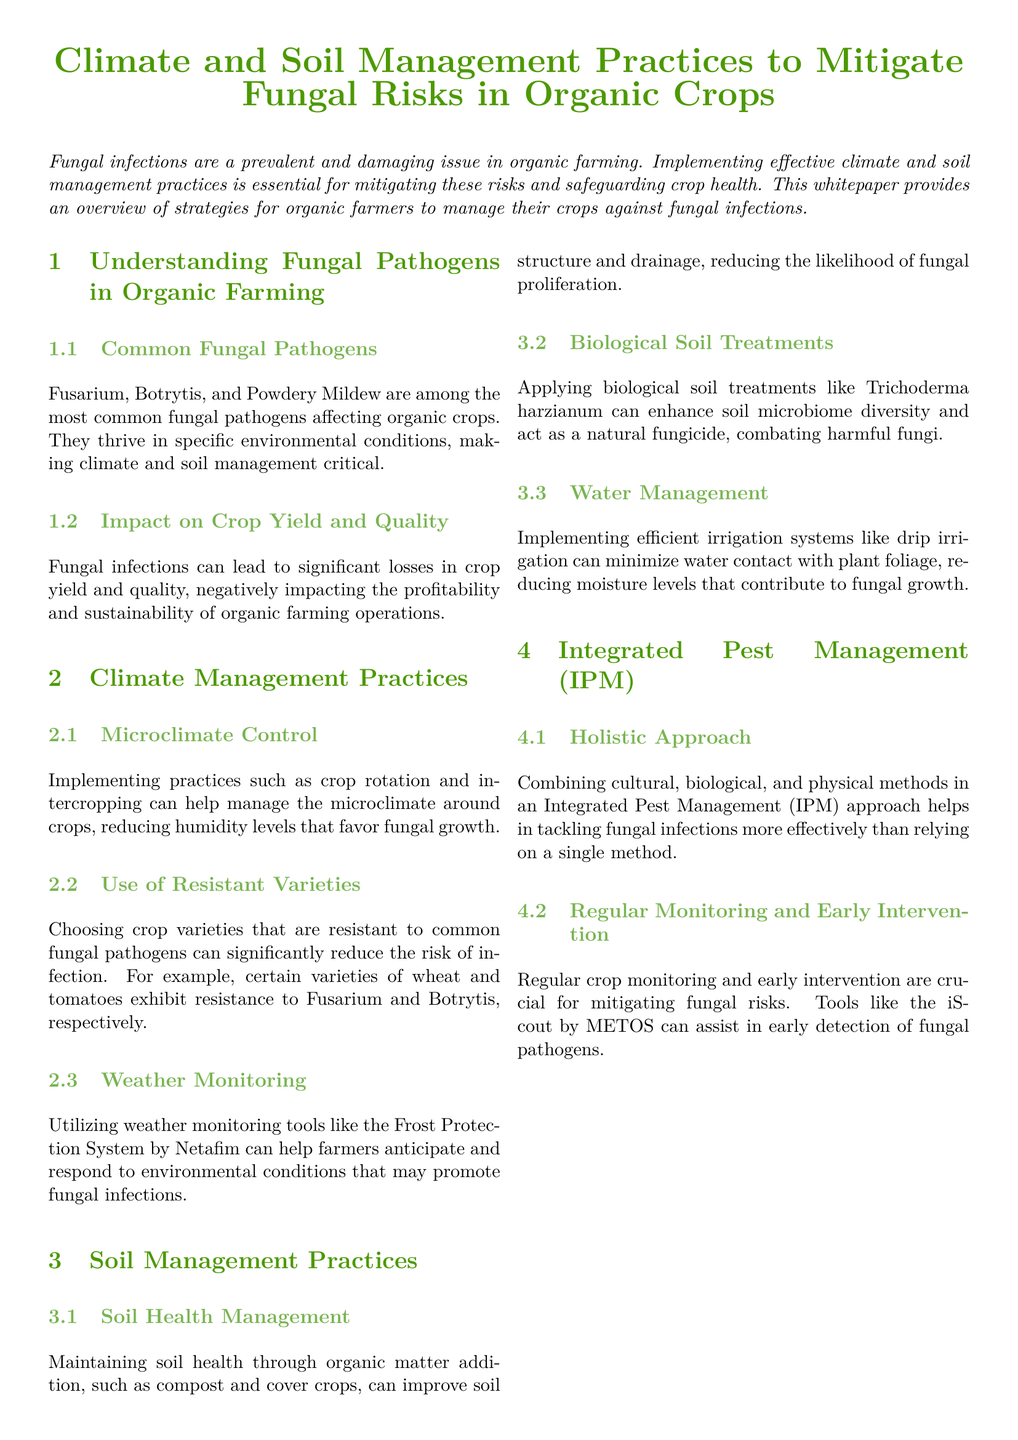What are common fungal pathogens in organic farming? The document lists Fusarium, Botrytis, and Powdery Mildew as common fungal pathogens affecting organic crops.
Answer: Fusarium, Botrytis, Powdery Mildew What management practice can help manage microclimate? The document suggests implementing crop rotation and intercropping as practices to manage the microclimate around crops.
Answer: Crop rotation, intercropping Which crop varieties can reduce the risk of infection? The document mentions that certain varieties of wheat and tomatoes exhibit resistance to Fusarium and Botrytis, respectively.
Answer: Wheat, tomatoes What is the benefit of maintaining soil health? Maintaining soil health through organic matter addition can improve soil structure and drainage, thus reducing the likelihood of fungal proliferation.
Answer: Improve soil structure and drainage What approach combines cultural, biological, and physical methods? The document describes an Integrated Pest Management (IPM) approach that combines these methods to tackle fungal infections.
Answer: Integrated Pest Management (IPM) Which treatment enhances soil microbiome diversity? The document states that applying biological soil treatments, specifically Trichoderma harzianum, enhances soil microbiome diversity.
Answer: Trichoderma harzianum How can farmers anticipate fungal infection conditions? Farmers can utilize weather monitoring tools, such as the Frost Protection System by Netafim, to anticipate environmental conditions promoting fungal infections.
Answer: Frost Protection System by Netafim What tool assists in early detection of fungal pathogens? The document refers to the iScout by METOS as a tool that can assist in early detection of fungal pathogens.
Answer: iScout by METOS What is the focus of the conclusion in the document? The conclusion emphasizes adopting tailored climate and soil management practices to mitigate fungal risks.
Answer: Mitigate fungal risks 